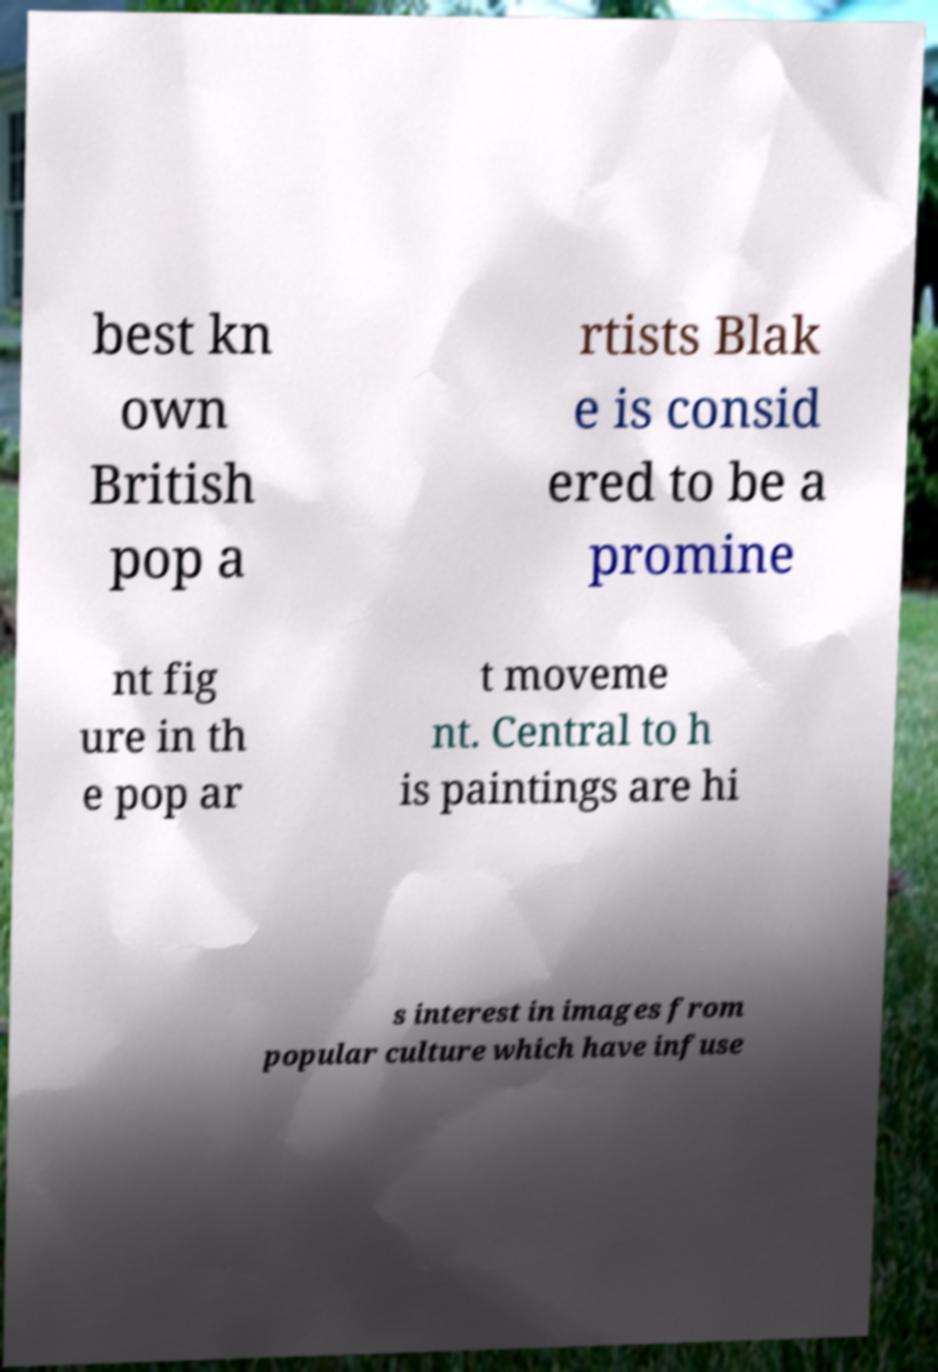Could you assist in decoding the text presented in this image and type it out clearly? best kn own British pop a rtists Blak e is consid ered to be a promine nt fig ure in th e pop ar t moveme nt. Central to h is paintings are hi s interest in images from popular culture which have infuse 